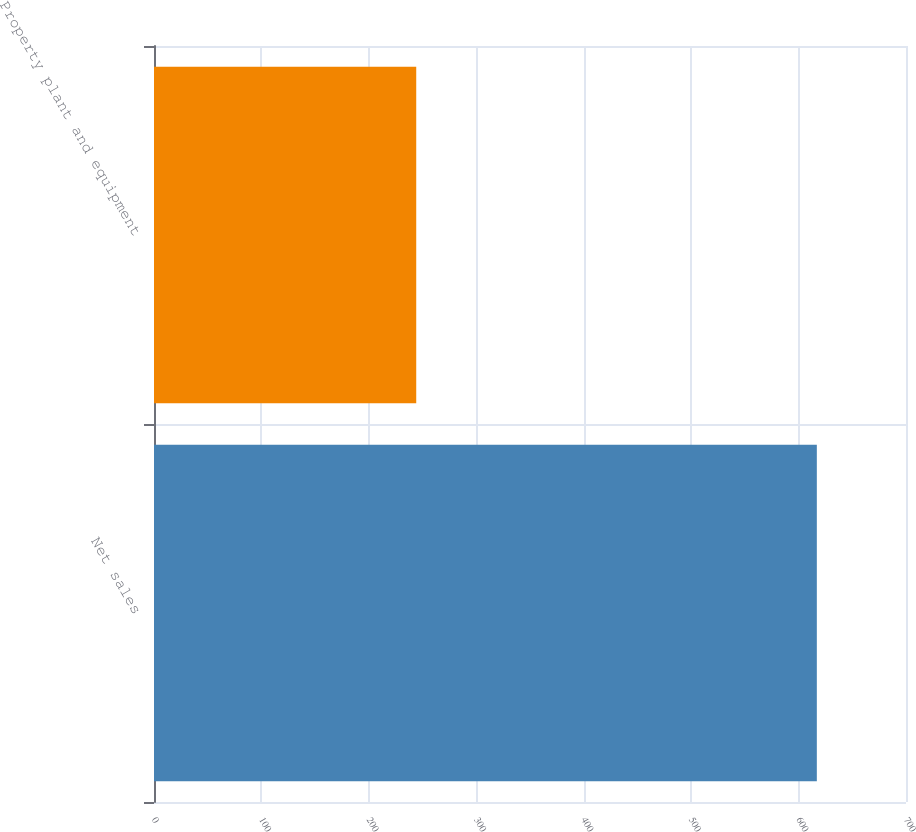<chart> <loc_0><loc_0><loc_500><loc_500><bar_chart><fcel>Net sales<fcel>Property plant and equipment<nl><fcel>617<fcel>244.1<nl></chart> 